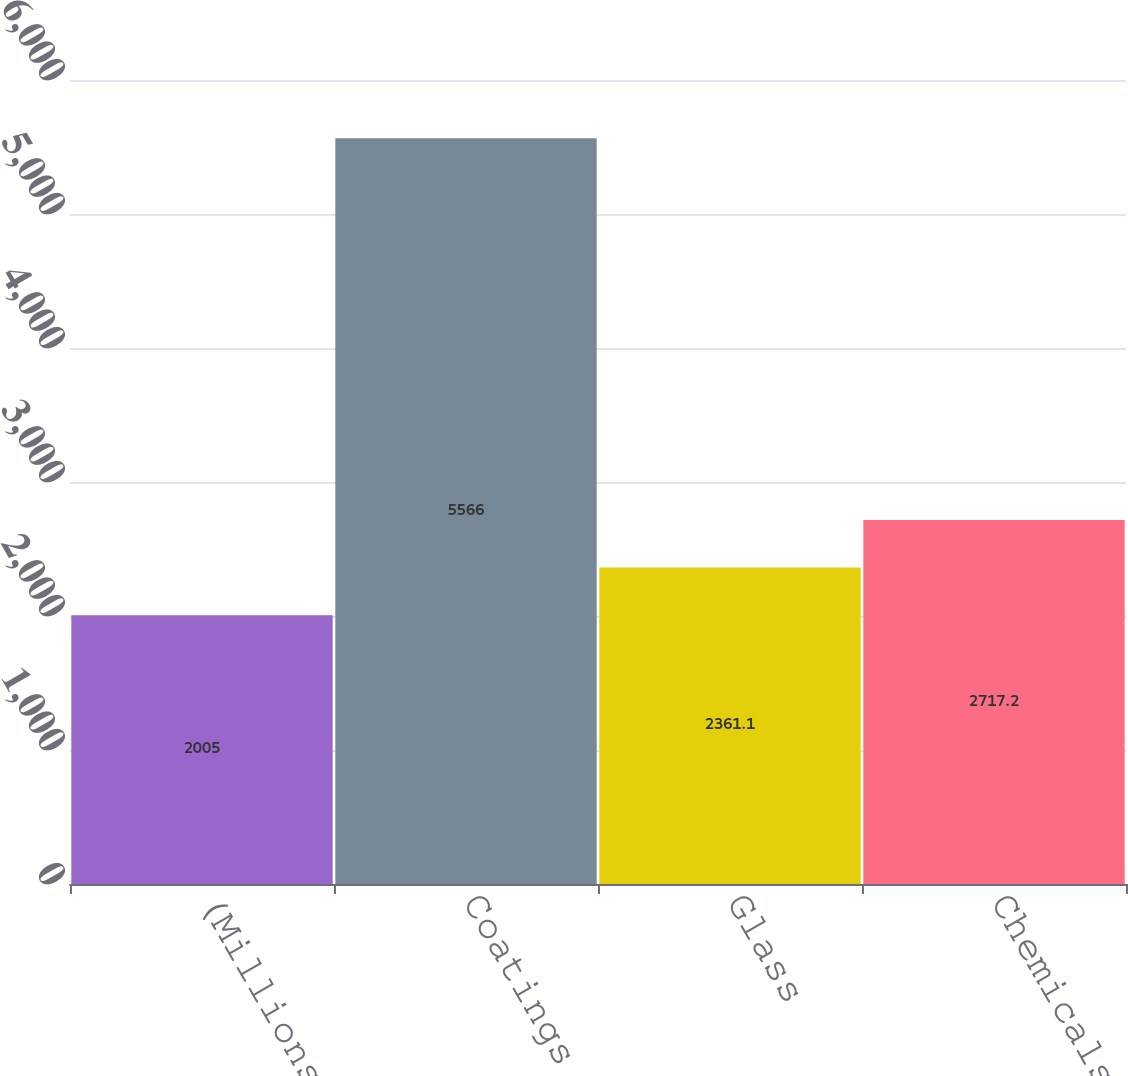Convert chart to OTSL. <chart><loc_0><loc_0><loc_500><loc_500><bar_chart><fcel>(Millions)<fcel>Coatings<fcel>Glass<fcel>Chemicals<nl><fcel>2005<fcel>5566<fcel>2361.1<fcel>2717.2<nl></chart> 